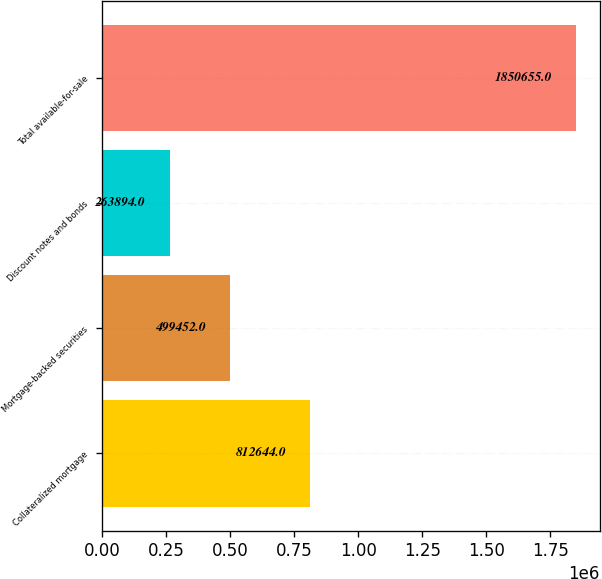<chart> <loc_0><loc_0><loc_500><loc_500><bar_chart><fcel>Collateralized mortgage<fcel>Mortgage-backed securities<fcel>Discount notes and bonds<fcel>Total available-for-sale<nl><fcel>812644<fcel>499452<fcel>263894<fcel>1.85066e+06<nl></chart> 